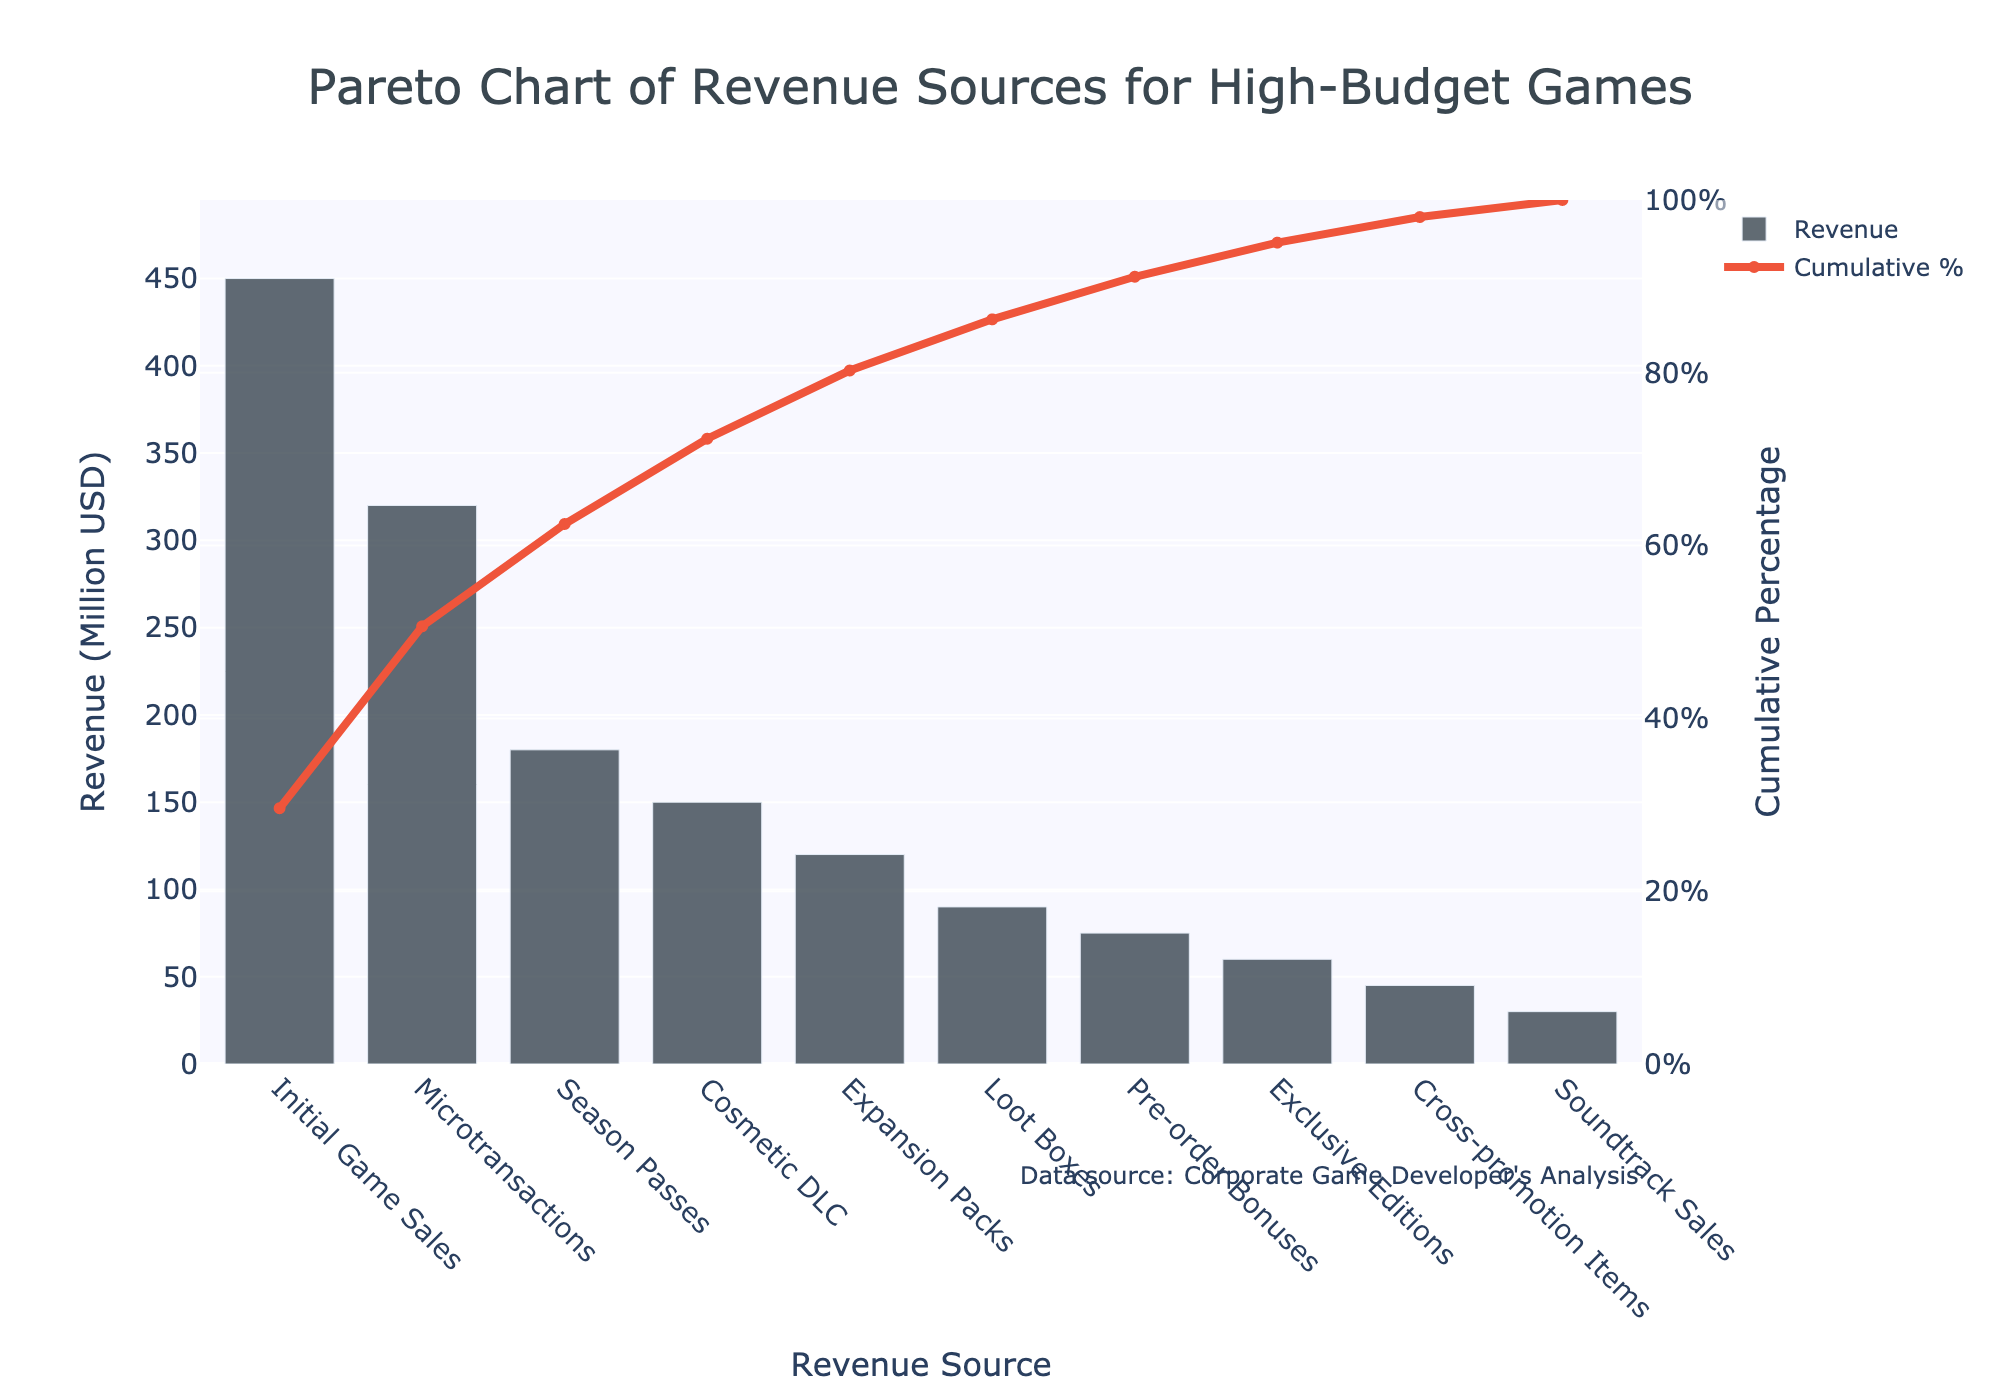what is the title of the chart? The title is written in the largest font at the top of the chart. It clearly describes what the chart is about.
Answer: Pareto Chart of Revenue Sources for High-Budget Games What is the revenue source with the highest amount? The revenue source with the highest amount can be found by looking at the tallest bar in the chart.
Answer: Initial Game Sales How much revenue in million USD do microtransactions generate? The height of the bar labeled "Microtransactions" indicates the amount of revenue it generates, and its hover template can provide the exact value.
Answer: 320 Million USD Which revenue sources contribute to the first 80% of cumulative revenue? By observing the cumulative percentage line, the revenue sources that cumulatively add up to 80% should be identified. Start from the top and go progressively downwards until the cumulative percentage reaches 80%.
Answer: Initial Game Sales, Microtransactions, and Season Passes What is the smallest revenue source in the chart? The revenue source with the smallest amount can be identified by finding the shortest bar.
Answer: Soundtrack Sales What's the combined revenue generated by Initial Game Sales and Microtransactions? Add the revenue from the bars labeled "Initial Game Sales" and "Microtransactions". Based on the amounts shown: 450 + 320.
Answer: 770 Million USD How much more revenue does Initial Game Sales generate compared to Expansion Packs? Subtract the revenue of "Expansion Packs" from "Initial Game Sales". Based on the amounts shown: 450 - 120.
Answer: 330 Million USD Which revenue source marks the 50% cumulative revenue point on the line? Follow the cumulative percentage line until it reaches or passes 50%, then check the corresponding bar right below that point.
Answer: Microtransactions What is the cumulative percentage after adding the revenue from Season Passes? Look for the cumulative percentage value that aligns with the top of the bar labeled "Season Passes".
Answer: 77% How many revenue sources in total are listed in the chart? Count the number of bars present in the chart as well as their respective labels.
Answer: 10 